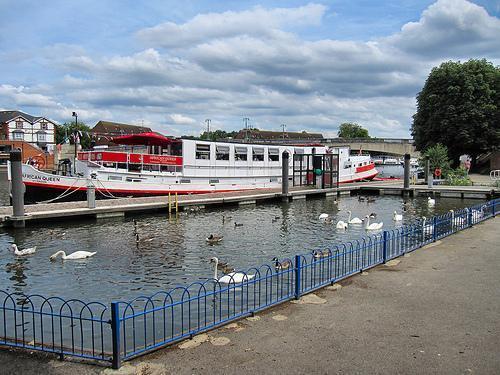How many boats are there?
Give a very brief answer. 1. 